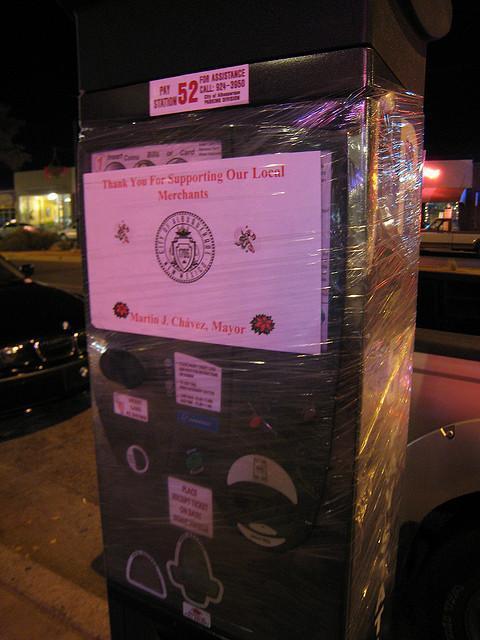How many cars can be seen?
Give a very brief answer. 2. 